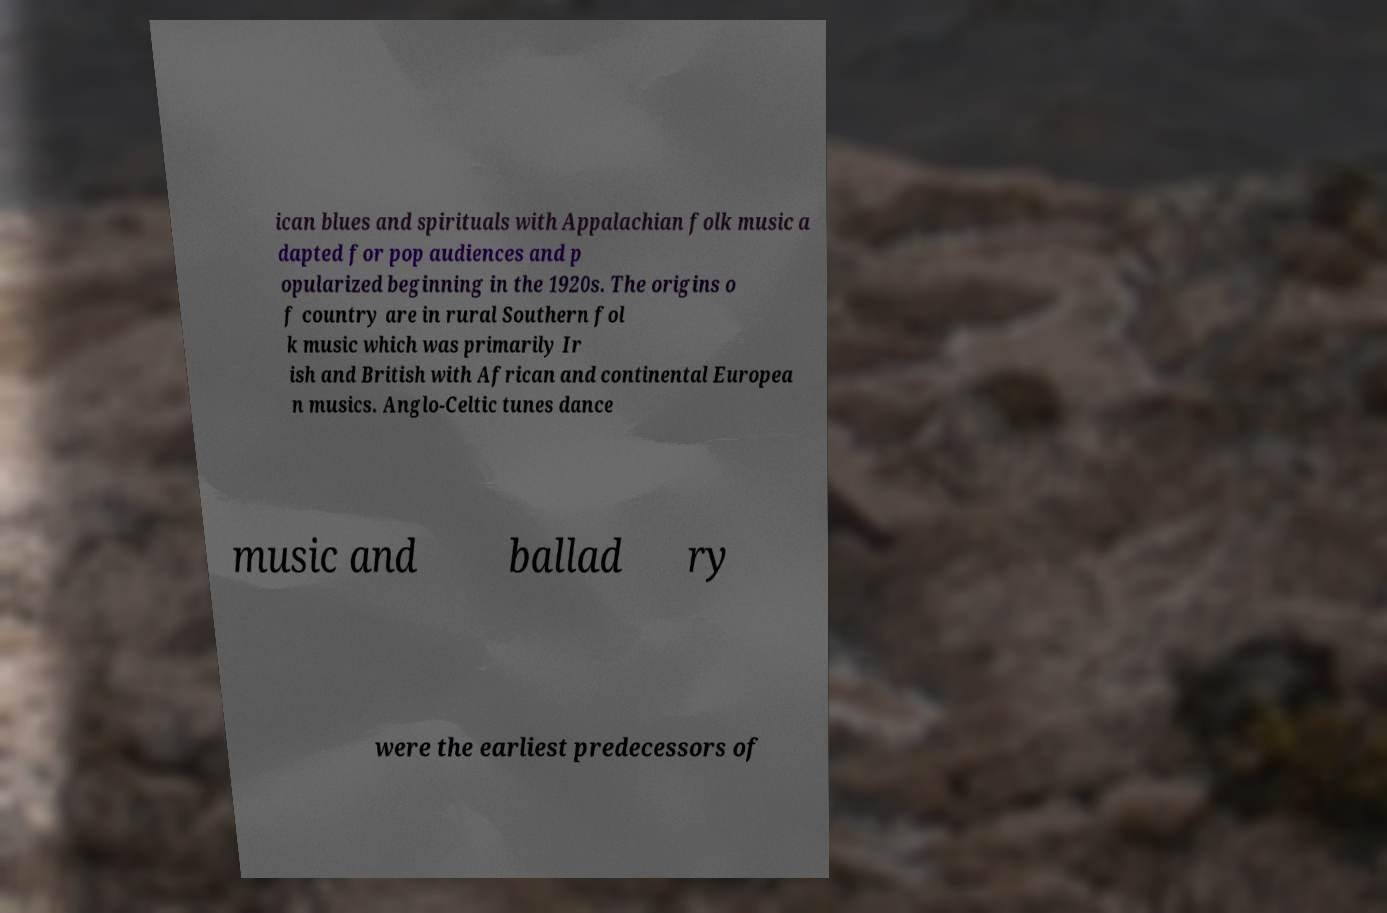What messages or text are displayed in this image? I need them in a readable, typed format. ican blues and spirituals with Appalachian folk music a dapted for pop audiences and p opularized beginning in the 1920s. The origins o f country are in rural Southern fol k music which was primarily Ir ish and British with African and continental Europea n musics. Anglo-Celtic tunes dance music and ballad ry were the earliest predecessors of 